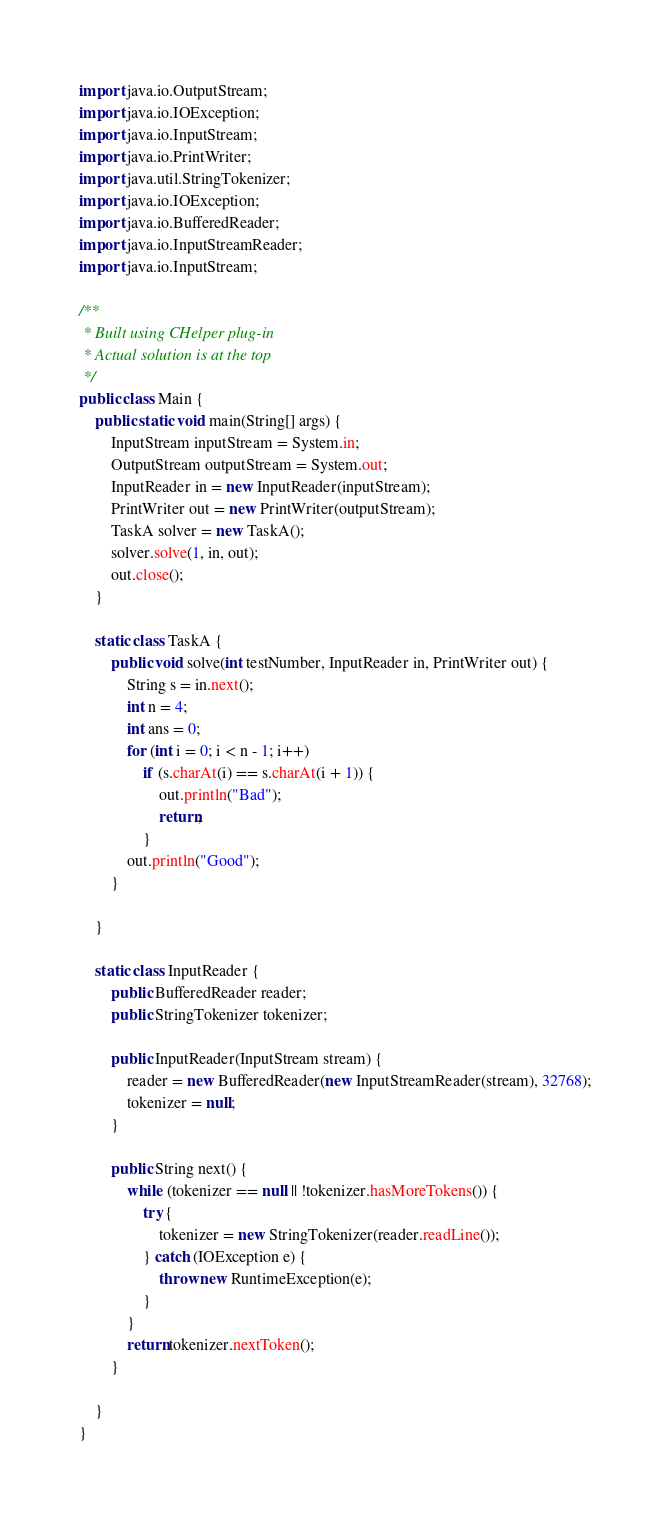<code> <loc_0><loc_0><loc_500><loc_500><_Java_>import java.io.OutputStream;
import java.io.IOException;
import java.io.InputStream;
import java.io.PrintWriter;
import java.util.StringTokenizer;
import java.io.IOException;
import java.io.BufferedReader;
import java.io.InputStreamReader;
import java.io.InputStream;

/**
 * Built using CHelper plug-in
 * Actual solution is at the top
 */
public class Main {
    public static void main(String[] args) {
        InputStream inputStream = System.in;
        OutputStream outputStream = System.out;
        InputReader in = new InputReader(inputStream);
        PrintWriter out = new PrintWriter(outputStream);
        TaskA solver = new TaskA();
        solver.solve(1, in, out);
        out.close();
    }

    static class TaskA {
        public void solve(int testNumber, InputReader in, PrintWriter out) {
            String s = in.next();
            int n = 4;
            int ans = 0;
            for (int i = 0; i < n - 1; i++)
                if (s.charAt(i) == s.charAt(i + 1)) {
                    out.println("Bad");
                    return;
                }
            out.println("Good");
        }

    }

    static class InputReader {
        public BufferedReader reader;
        public StringTokenizer tokenizer;

        public InputReader(InputStream stream) {
            reader = new BufferedReader(new InputStreamReader(stream), 32768);
            tokenizer = null;
        }

        public String next() {
            while (tokenizer == null || !tokenizer.hasMoreTokens()) {
                try {
                    tokenizer = new StringTokenizer(reader.readLine());
                } catch (IOException e) {
                    throw new RuntimeException(e);
                }
            }
            return tokenizer.nextToken();
        }

    }
}

</code> 